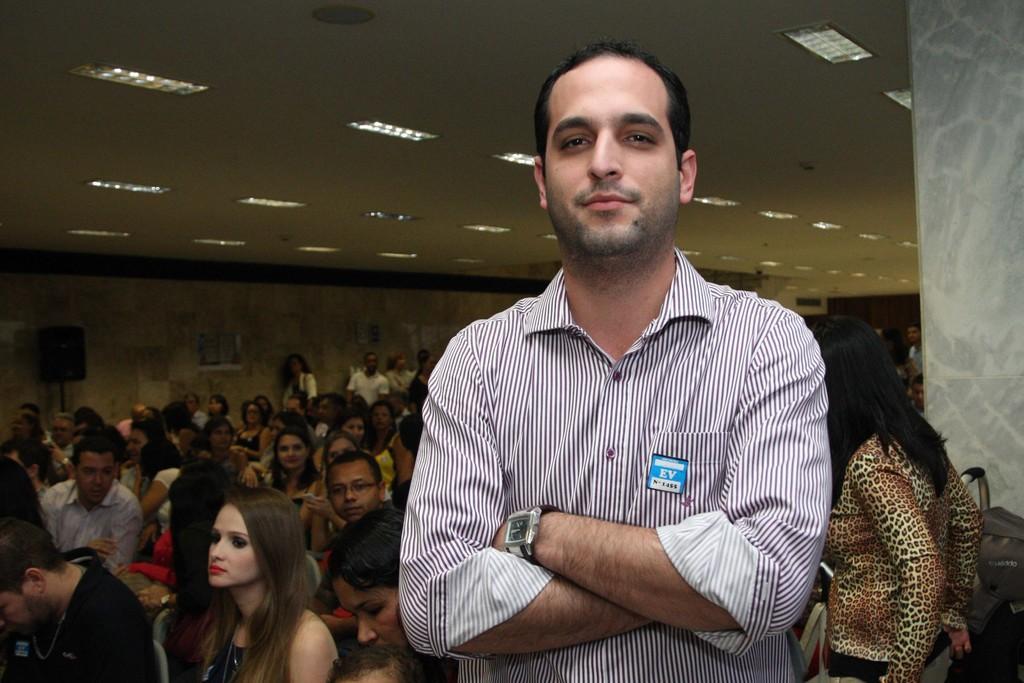Please provide a concise description of this image. In this image there is a person standing, behind this person there are so many people sitting and standing. In the background there is a wall and there is a speaker. At the top of the image there is a ceiling with lights. On the right side of the image there is a pillar. 